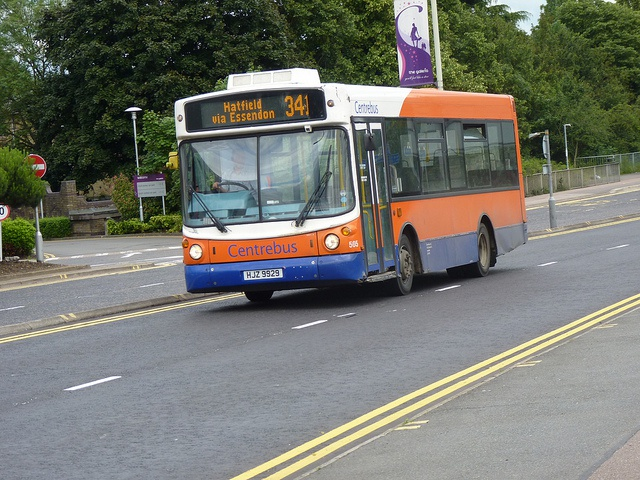Describe the objects in this image and their specific colors. I can see bus in darkgreen, gray, black, white, and darkgray tones, people in darkgreen, darkgray, gray, and lightgray tones, and traffic light in darkgreen, olive, and khaki tones in this image. 